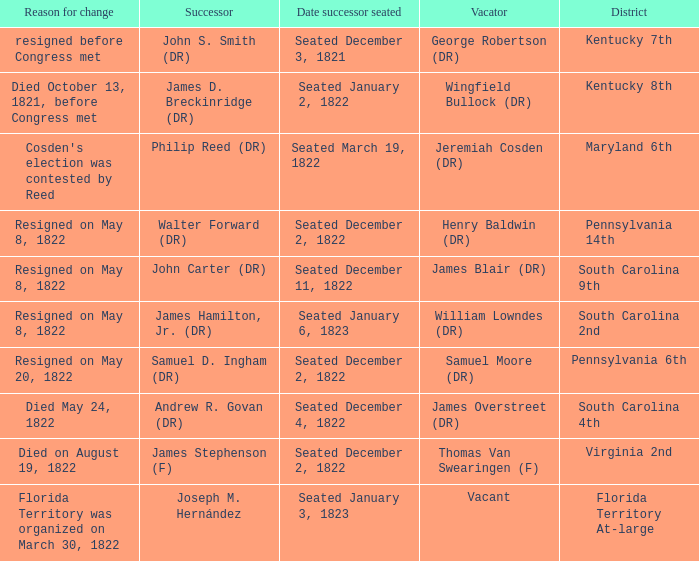Who is the vacator when south carolina 4th is the district? James Overstreet (DR). 